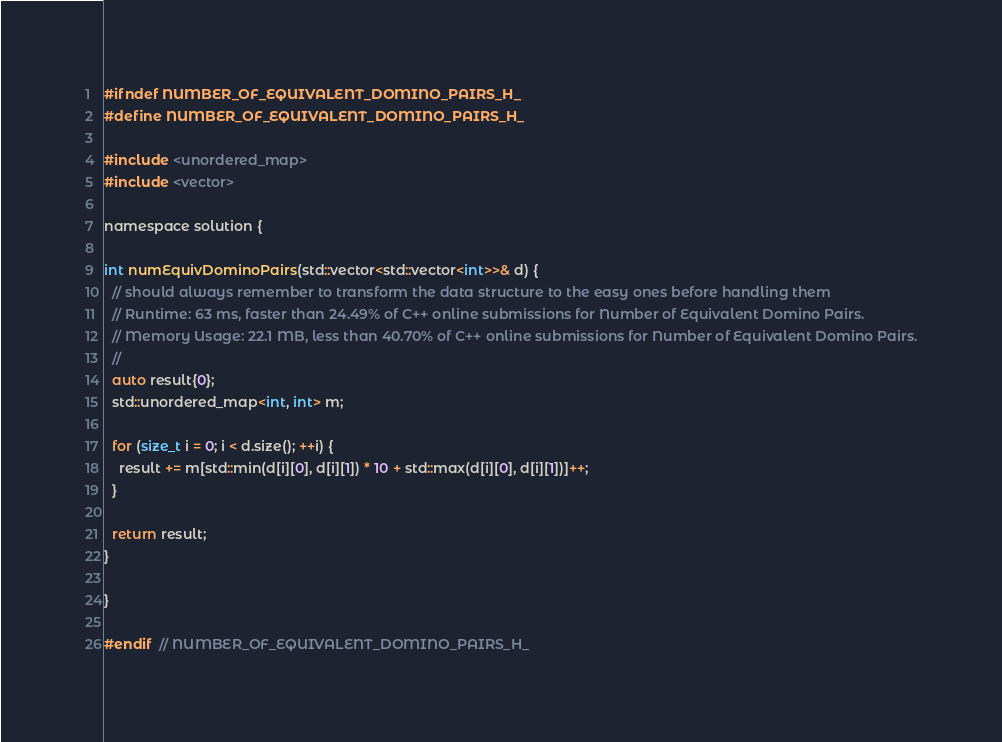<code> <loc_0><loc_0><loc_500><loc_500><_C_>#ifndef NUMBER_OF_EQUIVALENT_DOMINO_PAIRS_H_
#define NUMBER_OF_EQUIVALENT_DOMINO_PAIRS_H_

#include <unordered_map>
#include <vector>

namespace solution {

int numEquivDominoPairs(std::vector<std::vector<int>>& d) {
  // should always remember to transform the data structure to the easy ones before handling them
  // Runtime: 63 ms, faster than 24.49% of C++ online submissions for Number of Equivalent Domino Pairs.
  // Memory Usage: 22.1 MB, less than 40.70% of C++ online submissions for Number of Equivalent Domino Pairs.
  //
  auto result{0};
  std::unordered_map<int, int> m;

  for (size_t i = 0; i < d.size(); ++i) {
    result += m[std::min(d[i][0], d[i][1]) * 10 + std::max(d[i][0], d[i][1])]++;
  }

  return result;
}

}

#endif  // NUMBER_OF_EQUIVALENT_DOMINO_PAIRS_H_
</code> 